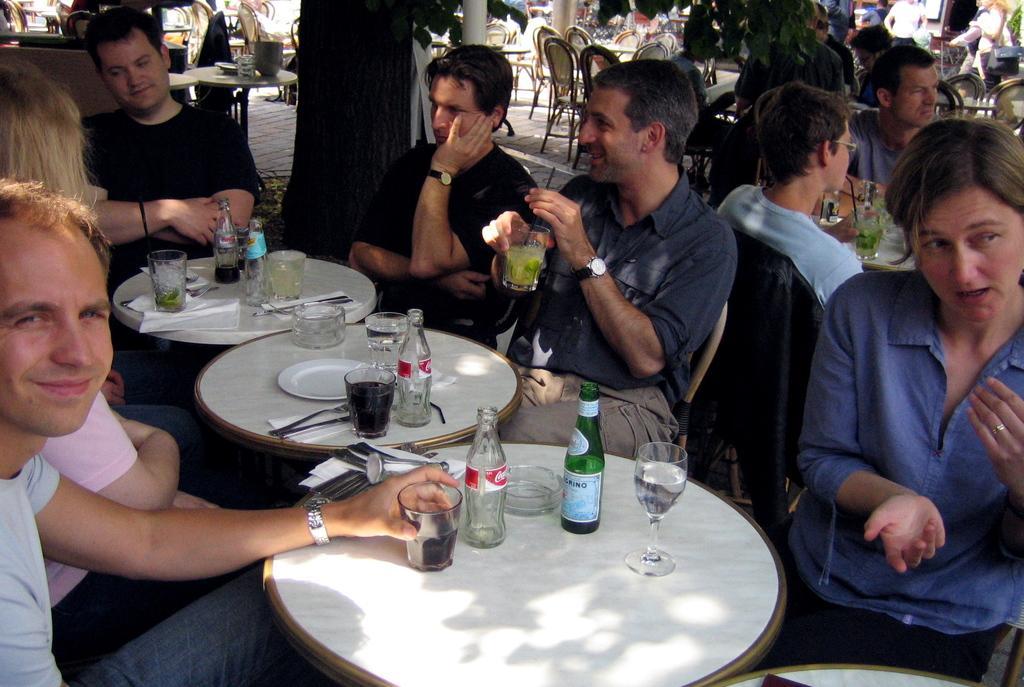Can you describe this image briefly? In this image, There are some table which are covered by a white cloth and there are some glasses and bottles and there are some people sitting around the table and in the background there are some people sitting on the chairs. 